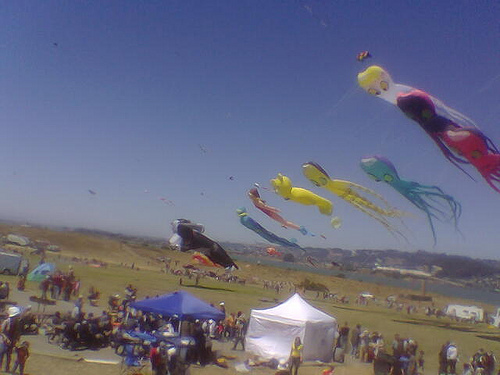Can you describe the event that seems to be taking place? Certainly! The image depicts an outdoor kite festival, characterized by the numerous colorful kites of various shapes and sizes flying high in the sky. The event is likely to be a gathering of kite enthusiasts and families enjoying the outdoor activity in an open field, evident from the people seen around and the kites dominating the skyline.  What might be the weather conditions during this event? Based on the clear blue sky and the successful flight of the kites, it can be inferred that the weather is favorable for kite flying – likely a sunny day with a steady breeze, which is perfect for keeping the kites aloft and maneuverable.  What do the different kite designs suggest about the festival? The varied and creative designs of the kites suggest that this festival celebrates the artistry and craftsmanship within kite making. The array of shapes, ranging from animals to intricate geometric patterns, indicates a playful atmosphere where the aesthetics of the kites are as significant as their flying capabilities, likely encouraging participants to express individuality and creativity. 